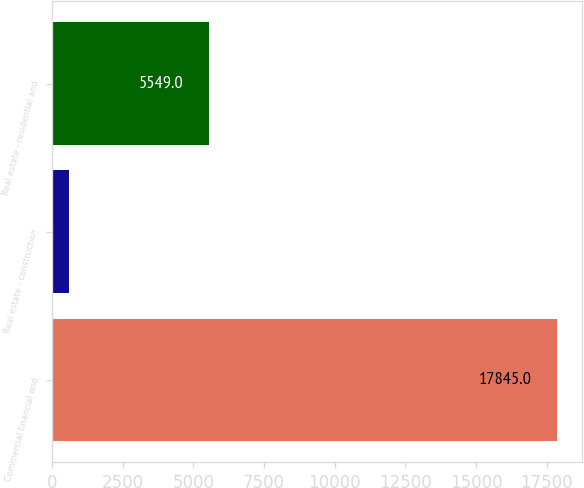Convert chart. <chart><loc_0><loc_0><loc_500><loc_500><bar_chart><fcel>Commercial financial and<fcel>Real estate - construction<fcel>Real estate - residential and<nl><fcel>17845<fcel>596<fcel>5549<nl></chart> 